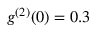<formula> <loc_0><loc_0><loc_500><loc_500>g ^ { ( 2 ) } ( 0 ) = 0 . 3</formula> 